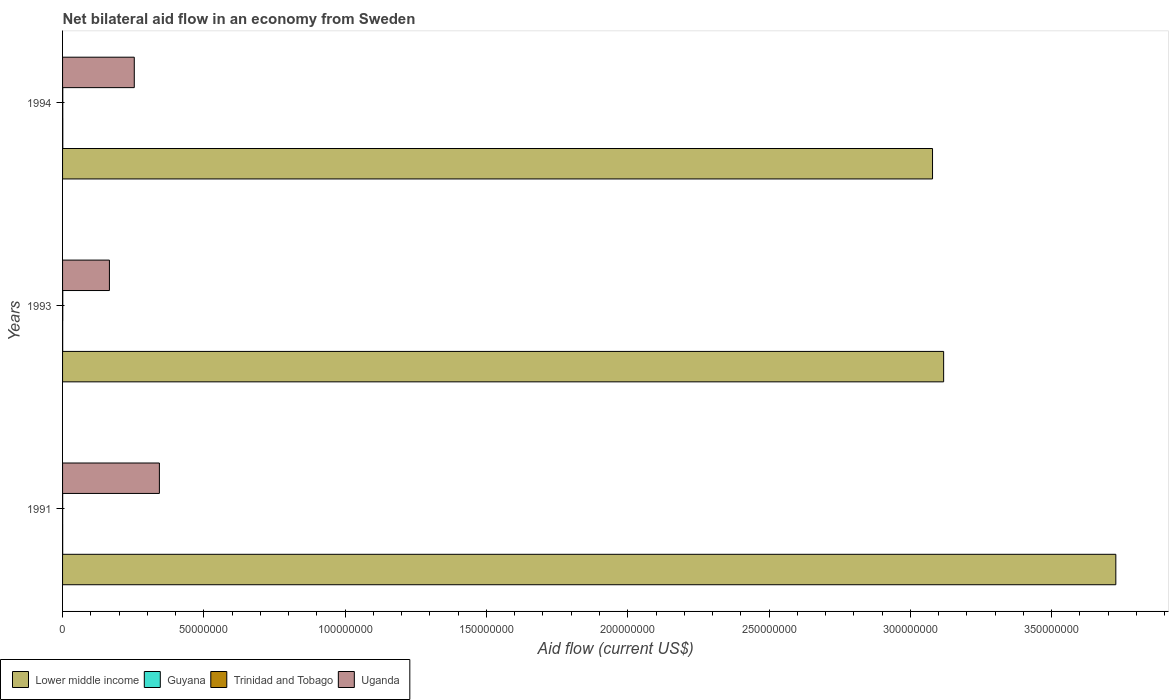How many different coloured bars are there?
Your response must be concise. 4. Are the number of bars per tick equal to the number of legend labels?
Offer a terse response. Yes. Are the number of bars on each tick of the Y-axis equal?
Offer a very short reply. Yes. How many bars are there on the 3rd tick from the bottom?
Your response must be concise. 4. What is the label of the 3rd group of bars from the top?
Ensure brevity in your answer.  1991. In how many cases, is the number of bars for a given year not equal to the number of legend labels?
Provide a short and direct response. 0. Across all years, what is the maximum net bilateral aid flow in Trinidad and Tobago?
Offer a very short reply. 7.00e+04. Across all years, what is the minimum net bilateral aid flow in Trinidad and Tobago?
Keep it short and to the point. 3.00e+04. What is the total net bilateral aid flow in Trinidad and Tobago in the graph?
Offer a terse response. 1.70e+05. What is the difference between the net bilateral aid flow in Uganda in 1993 and that in 1994?
Provide a short and direct response. -8.80e+06. What is the difference between the net bilateral aid flow in Uganda in 1993 and the net bilateral aid flow in Guyana in 1991?
Provide a short and direct response. 1.65e+07. What is the average net bilateral aid flow in Lower middle income per year?
Make the answer very short. 3.31e+08. In the year 1994, what is the difference between the net bilateral aid flow in Lower middle income and net bilateral aid flow in Guyana?
Ensure brevity in your answer.  3.08e+08. What is the ratio of the net bilateral aid flow in Uganda in 1993 to that in 1994?
Your answer should be very brief. 0.65. Is the net bilateral aid flow in Uganda in 1991 less than that in 1994?
Offer a very short reply. No. Is the difference between the net bilateral aid flow in Lower middle income in 1991 and 1993 greater than the difference between the net bilateral aid flow in Guyana in 1991 and 1993?
Ensure brevity in your answer.  Yes. In how many years, is the net bilateral aid flow in Uganda greater than the average net bilateral aid flow in Uganda taken over all years?
Provide a succinct answer. 1. Is it the case that in every year, the sum of the net bilateral aid flow in Lower middle income and net bilateral aid flow in Trinidad and Tobago is greater than the sum of net bilateral aid flow in Uganda and net bilateral aid flow in Guyana?
Keep it short and to the point. Yes. What does the 4th bar from the top in 1991 represents?
Provide a succinct answer. Lower middle income. What does the 2nd bar from the bottom in 1991 represents?
Your answer should be very brief. Guyana. How many bars are there?
Offer a terse response. 12. How many years are there in the graph?
Offer a very short reply. 3. Does the graph contain any zero values?
Make the answer very short. No. What is the title of the graph?
Ensure brevity in your answer.  Net bilateral aid flow in an economy from Sweden. What is the label or title of the X-axis?
Offer a terse response. Aid flow (current US$). What is the label or title of the Y-axis?
Provide a short and direct response. Years. What is the Aid flow (current US$) in Lower middle income in 1991?
Make the answer very short. 3.73e+08. What is the Aid flow (current US$) in Uganda in 1991?
Your response must be concise. 3.43e+07. What is the Aid flow (current US$) in Lower middle income in 1993?
Your answer should be very brief. 3.12e+08. What is the Aid flow (current US$) of Uganda in 1993?
Ensure brevity in your answer.  1.66e+07. What is the Aid flow (current US$) of Lower middle income in 1994?
Provide a succinct answer. 3.08e+08. What is the Aid flow (current US$) of Guyana in 1994?
Ensure brevity in your answer.  8.00e+04. What is the Aid flow (current US$) of Trinidad and Tobago in 1994?
Your response must be concise. 7.00e+04. What is the Aid flow (current US$) of Uganda in 1994?
Your answer should be very brief. 2.54e+07. Across all years, what is the maximum Aid flow (current US$) of Lower middle income?
Your answer should be very brief. 3.73e+08. Across all years, what is the maximum Aid flow (current US$) of Uganda?
Your answer should be very brief. 3.43e+07. Across all years, what is the minimum Aid flow (current US$) in Lower middle income?
Provide a succinct answer. 3.08e+08. Across all years, what is the minimum Aid flow (current US$) of Guyana?
Provide a short and direct response. 4.00e+04. Across all years, what is the minimum Aid flow (current US$) in Uganda?
Ensure brevity in your answer.  1.66e+07. What is the total Aid flow (current US$) of Lower middle income in the graph?
Your answer should be compact. 9.92e+08. What is the total Aid flow (current US$) of Guyana in the graph?
Ensure brevity in your answer.  1.60e+05. What is the total Aid flow (current US$) in Trinidad and Tobago in the graph?
Provide a succinct answer. 1.70e+05. What is the total Aid flow (current US$) in Uganda in the graph?
Provide a short and direct response. 7.62e+07. What is the difference between the Aid flow (current US$) of Lower middle income in 1991 and that in 1993?
Provide a succinct answer. 6.09e+07. What is the difference between the Aid flow (current US$) in Trinidad and Tobago in 1991 and that in 1993?
Offer a terse response. -4.00e+04. What is the difference between the Aid flow (current US$) of Uganda in 1991 and that in 1993?
Provide a succinct answer. 1.77e+07. What is the difference between the Aid flow (current US$) in Lower middle income in 1991 and that in 1994?
Provide a short and direct response. 6.49e+07. What is the difference between the Aid flow (current US$) in Guyana in 1991 and that in 1994?
Ensure brevity in your answer.  -4.00e+04. What is the difference between the Aid flow (current US$) in Uganda in 1991 and that in 1994?
Your response must be concise. 8.88e+06. What is the difference between the Aid flow (current US$) of Lower middle income in 1993 and that in 1994?
Provide a short and direct response. 3.93e+06. What is the difference between the Aid flow (current US$) of Guyana in 1993 and that in 1994?
Your answer should be compact. -4.00e+04. What is the difference between the Aid flow (current US$) in Uganda in 1993 and that in 1994?
Offer a very short reply. -8.80e+06. What is the difference between the Aid flow (current US$) of Lower middle income in 1991 and the Aid flow (current US$) of Guyana in 1993?
Ensure brevity in your answer.  3.73e+08. What is the difference between the Aid flow (current US$) of Lower middle income in 1991 and the Aid flow (current US$) of Trinidad and Tobago in 1993?
Keep it short and to the point. 3.73e+08. What is the difference between the Aid flow (current US$) in Lower middle income in 1991 and the Aid flow (current US$) in Uganda in 1993?
Make the answer very short. 3.56e+08. What is the difference between the Aid flow (current US$) in Guyana in 1991 and the Aid flow (current US$) in Trinidad and Tobago in 1993?
Give a very brief answer. -3.00e+04. What is the difference between the Aid flow (current US$) in Guyana in 1991 and the Aid flow (current US$) in Uganda in 1993?
Make the answer very short. -1.65e+07. What is the difference between the Aid flow (current US$) in Trinidad and Tobago in 1991 and the Aid flow (current US$) in Uganda in 1993?
Ensure brevity in your answer.  -1.66e+07. What is the difference between the Aid flow (current US$) of Lower middle income in 1991 and the Aid flow (current US$) of Guyana in 1994?
Offer a terse response. 3.73e+08. What is the difference between the Aid flow (current US$) of Lower middle income in 1991 and the Aid flow (current US$) of Trinidad and Tobago in 1994?
Your response must be concise. 3.73e+08. What is the difference between the Aid flow (current US$) in Lower middle income in 1991 and the Aid flow (current US$) in Uganda in 1994?
Provide a short and direct response. 3.47e+08. What is the difference between the Aid flow (current US$) of Guyana in 1991 and the Aid flow (current US$) of Uganda in 1994?
Give a very brief answer. -2.53e+07. What is the difference between the Aid flow (current US$) of Trinidad and Tobago in 1991 and the Aid flow (current US$) of Uganda in 1994?
Offer a very short reply. -2.54e+07. What is the difference between the Aid flow (current US$) in Lower middle income in 1993 and the Aid flow (current US$) in Guyana in 1994?
Make the answer very short. 3.12e+08. What is the difference between the Aid flow (current US$) in Lower middle income in 1993 and the Aid flow (current US$) in Trinidad and Tobago in 1994?
Make the answer very short. 3.12e+08. What is the difference between the Aid flow (current US$) in Lower middle income in 1993 and the Aid flow (current US$) in Uganda in 1994?
Your answer should be very brief. 2.86e+08. What is the difference between the Aid flow (current US$) of Guyana in 1993 and the Aid flow (current US$) of Uganda in 1994?
Provide a short and direct response. -2.53e+07. What is the difference between the Aid flow (current US$) of Trinidad and Tobago in 1993 and the Aid flow (current US$) of Uganda in 1994?
Provide a succinct answer. -2.53e+07. What is the average Aid flow (current US$) in Lower middle income per year?
Offer a very short reply. 3.31e+08. What is the average Aid flow (current US$) of Guyana per year?
Provide a short and direct response. 5.33e+04. What is the average Aid flow (current US$) in Trinidad and Tobago per year?
Ensure brevity in your answer.  5.67e+04. What is the average Aid flow (current US$) of Uganda per year?
Keep it short and to the point. 2.54e+07. In the year 1991, what is the difference between the Aid flow (current US$) in Lower middle income and Aid flow (current US$) in Guyana?
Ensure brevity in your answer.  3.73e+08. In the year 1991, what is the difference between the Aid flow (current US$) of Lower middle income and Aid flow (current US$) of Trinidad and Tobago?
Keep it short and to the point. 3.73e+08. In the year 1991, what is the difference between the Aid flow (current US$) of Lower middle income and Aid flow (current US$) of Uganda?
Offer a very short reply. 3.38e+08. In the year 1991, what is the difference between the Aid flow (current US$) of Guyana and Aid flow (current US$) of Uganda?
Provide a short and direct response. -3.42e+07. In the year 1991, what is the difference between the Aid flow (current US$) of Trinidad and Tobago and Aid flow (current US$) of Uganda?
Your response must be concise. -3.42e+07. In the year 1993, what is the difference between the Aid flow (current US$) of Lower middle income and Aid flow (current US$) of Guyana?
Offer a terse response. 3.12e+08. In the year 1993, what is the difference between the Aid flow (current US$) of Lower middle income and Aid flow (current US$) of Trinidad and Tobago?
Offer a very short reply. 3.12e+08. In the year 1993, what is the difference between the Aid flow (current US$) in Lower middle income and Aid flow (current US$) in Uganda?
Give a very brief answer. 2.95e+08. In the year 1993, what is the difference between the Aid flow (current US$) in Guyana and Aid flow (current US$) in Trinidad and Tobago?
Your answer should be very brief. -3.00e+04. In the year 1993, what is the difference between the Aid flow (current US$) of Guyana and Aid flow (current US$) of Uganda?
Keep it short and to the point. -1.65e+07. In the year 1993, what is the difference between the Aid flow (current US$) in Trinidad and Tobago and Aid flow (current US$) in Uganda?
Your response must be concise. -1.65e+07. In the year 1994, what is the difference between the Aid flow (current US$) of Lower middle income and Aid flow (current US$) of Guyana?
Provide a short and direct response. 3.08e+08. In the year 1994, what is the difference between the Aid flow (current US$) of Lower middle income and Aid flow (current US$) of Trinidad and Tobago?
Offer a terse response. 3.08e+08. In the year 1994, what is the difference between the Aid flow (current US$) of Lower middle income and Aid flow (current US$) of Uganda?
Provide a short and direct response. 2.82e+08. In the year 1994, what is the difference between the Aid flow (current US$) of Guyana and Aid flow (current US$) of Uganda?
Your response must be concise. -2.53e+07. In the year 1994, what is the difference between the Aid flow (current US$) of Trinidad and Tobago and Aid flow (current US$) of Uganda?
Offer a terse response. -2.53e+07. What is the ratio of the Aid flow (current US$) in Lower middle income in 1991 to that in 1993?
Make the answer very short. 1.2. What is the ratio of the Aid flow (current US$) of Guyana in 1991 to that in 1993?
Offer a very short reply. 1. What is the ratio of the Aid flow (current US$) in Trinidad and Tobago in 1991 to that in 1993?
Offer a terse response. 0.43. What is the ratio of the Aid flow (current US$) of Uganda in 1991 to that in 1993?
Give a very brief answer. 2.07. What is the ratio of the Aid flow (current US$) of Lower middle income in 1991 to that in 1994?
Give a very brief answer. 1.21. What is the ratio of the Aid flow (current US$) in Trinidad and Tobago in 1991 to that in 1994?
Give a very brief answer. 0.43. What is the ratio of the Aid flow (current US$) of Uganda in 1991 to that in 1994?
Offer a very short reply. 1.35. What is the ratio of the Aid flow (current US$) of Lower middle income in 1993 to that in 1994?
Provide a succinct answer. 1.01. What is the ratio of the Aid flow (current US$) in Uganda in 1993 to that in 1994?
Offer a terse response. 0.65. What is the difference between the highest and the second highest Aid flow (current US$) in Lower middle income?
Offer a terse response. 6.09e+07. What is the difference between the highest and the second highest Aid flow (current US$) of Trinidad and Tobago?
Make the answer very short. 0. What is the difference between the highest and the second highest Aid flow (current US$) of Uganda?
Make the answer very short. 8.88e+06. What is the difference between the highest and the lowest Aid flow (current US$) in Lower middle income?
Your answer should be compact. 6.49e+07. What is the difference between the highest and the lowest Aid flow (current US$) in Trinidad and Tobago?
Keep it short and to the point. 4.00e+04. What is the difference between the highest and the lowest Aid flow (current US$) in Uganda?
Your response must be concise. 1.77e+07. 